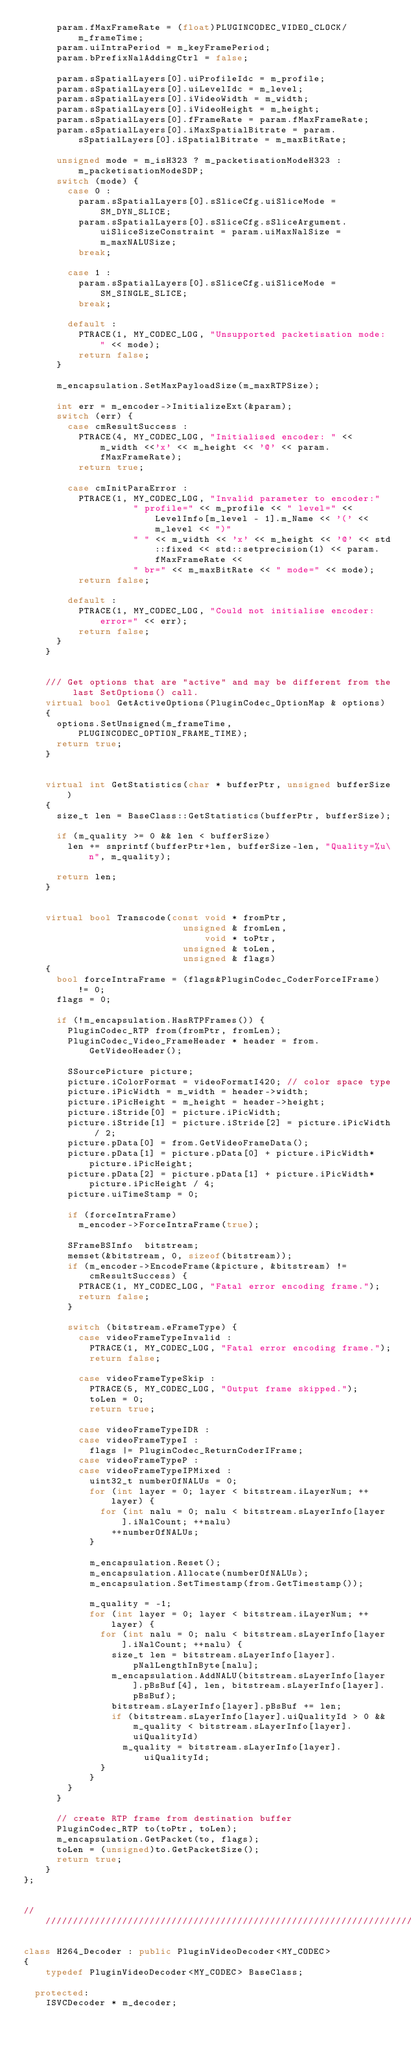<code> <loc_0><loc_0><loc_500><loc_500><_C++_>      param.fMaxFrameRate = (float)PLUGINCODEC_VIDEO_CLOCK/m_frameTime;
      param.uiIntraPeriod = m_keyFramePeriod;
      param.bPrefixNalAddingCtrl = false;

      param.sSpatialLayers[0].uiProfileIdc = m_profile;
      param.sSpatialLayers[0].uiLevelIdc = m_level;
      param.sSpatialLayers[0].iVideoWidth = m_width;
      param.sSpatialLayers[0].iVideoHeight = m_height;
      param.sSpatialLayers[0].fFrameRate = param.fMaxFrameRate;
      param.sSpatialLayers[0].iMaxSpatialBitrate = param.sSpatialLayers[0].iSpatialBitrate = m_maxBitRate;

      unsigned mode = m_isH323 ? m_packetisationModeH323 : m_packetisationModeSDP;
      switch (mode) {
        case 0 :
          param.sSpatialLayers[0].sSliceCfg.uiSliceMode = SM_DYN_SLICE;
          param.sSpatialLayers[0].sSliceCfg.sSliceArgument.uiSliceSizeConstraint = param.uiMaxNalSize = m_maxNALUSize;
          break;

        case 1 :
          param.sSpatialLayers[0].sSliceCfg.uiSliceMode = SM_SINGLE_SLICE;
          break;

        default :
          PTRACE(1, MY_CODEC_LOG, "Unsupported packetisation mode: " << mode);
          return false;
      }

      m_encapsulation.SetMaxPayloadSize(m_maxRTPSize);

      int err = m_encoder->InitializeExt(&param);
      switch (err) {
        case cmResultSuccess :
          PTRACE(4, MY_CODEC_LOG, "Initialised encoder: " << m_width <<'x' << m_height << '@' << param.fMaxFrameRate);
          return true;

        case cmInitParaError :
          PTRACE(1, MY_CODEC_LOG, "Invalid parameter to encoder:"
                    " profile=" << m_profile << " level=" << LevelInfo[m_level - 1].m_Name << '(' << m_level << ")"
                    " " << m_width << 'x' << m_height << '@' << std::fixed << std::setprecision(1) << param.fMaxFrameRate <<
                    " br=" << m_maxBitRate << " mode=" << mode);
          return false;

        default :
          PTRACE(1, MY_CODEC_LOG, "Could not initialise encoder: error=" << err);
          return false;
      }
    }


    /// Get options that are "active" and may be different from the last SetOptions() call.
    virtual bool GetActiveOptions(PluginCodec_OptionMap & options)
    {
      options.SetUnsigned(m_frameTime, PLUGINCODEC_OPTION_FRAME_TIME);
      return true;
    }


    virtual int GetStatistics(char * bufferPtr, unsigned bufferSize)
    {
      size_t len = BaseClass::GetStatistics(bufferPtr, bufferSize);

      if (m_quality >= 0 && len < bufferSize)
        len += snprintf(bufferPtr+len, bufferSize-len, "Quality=%u\n", m_quality);

      return len;
    }


    virtual bool Transcode(const void * fromPtr,
                             unsigned & fromLen,
                                 void * toPtr,
                             unsigned & toLen,
                             unsigned & flags)
    {
      bool forceIntraFrame = (flags&PluginCodec_CoderForceIFrame) != 0;
      flags = 0;

      if (!m_encapsulation.HasRTPFrames()) {
        PluginCodec_RTP from(fromPtr, fromLen);
        PluginCodec_Video_FrameHeader * header = from.GetVideoHeader();

        SSourcePicture picture;
        picture.iColorFormat = videoFormatI420;	// color space type
        picture.iPicWidth = m_width = header->width;
        picture.iPicHeight = m_height = header->height;
        picture.iStride[0] = picture.iPicWidth;
        picture.iStride[1] = picture.iStride[2] = picture.iPicWidth / 2;
        picture.pData[0] = from.GetVideoFrameData();
        picture.pData[1] = picture.pData[0] + picture.iPicWidth*picture.iPicHeight;
        picture.pData[2] = picture.pData[1] + picture.iPicWidth*picture.iPicHeight / 4;
        picture.uiTimeStamp = 0;

        if (forceIntraFrame)
          m_encoder->ForceIntraFrame(true);

        SFrameBSInfo  bitstream;
        memset(&bitstream, 0, sizeof(bitstream));
        if (m_encoder->EncodeFrame(&picture, &bitstream) != cmResultSuccess) {
          PTRACE(1, MY_CODEC_LOG, "Fatal error encoding frame.");
          return false;
        }

        switch (bitstream.eFrameType) {
          case videoFrameTypeInvalid :
            PTRACE(1, MY_CODEC_LOG, "Fatal error encoding frame.");
            return false;

          case videoFrameTypeSkip :
            PTRACE(5, MY_CODEC_LOG, "Output frame skipped.");
            toLen = 0;
            return true;

          case videoFrameTypeIDR :
          case videoFrameTypeI :
            flags |= PluginCodec_ReturnCoderIFrame;
          case videoFrameTypeP :
          case videoFrameTypeIPMixed :
            uint32_t numberOfNALUs = 0;
            for (int layer = 0; layer < bitstream.iLayerNum; ++layer) {
              for (int nalu = 0; nalu < bitstream.sLayerInfo[layer].iNalCount; ++nalu)
                ++numberOfNALUs;
            }

            m_encapsulation.Reset();
            m_encapsulation.Allocate(numberOfNALUs);
            m_encapsulation.SetTimestamp(from.GetTimestamp());

            m_quality = -1;
            for (int layer = 0; layer < bitstream.iLayerNum; ++layer) {
              for (int nalu = 0; nalu < bitstream.sLayerInfo[layer].iNalCount; ++nalu) {
                size_t len = bitstream.sLayerInfo[layer].pNalLengthInByte[nalu];
                m_encapsulation.AddNALU(bitstream.sLayerInfo[layer].pBsBuf[4], len, bitstream.sLayerInfo[layer].pBsBuf);
                bitstream.sLayerInfo[layer].pBsBuf += len;
                if (bitstream.sLayerInfo[layer].uiQualityId > 0 && m_quality < bitstream.sLayerInfo[layer].uiQualityId)
                  m_quality = bitstream.sLayerInfo[layer].uiQualityId;
              }
            }
        }
      }

      // create RTP frame from destination buffer
      PluginCodec_RTP to(toPtr, toLen);
      m_encapsulation.GetPacket(to, flags);
      toLen = (unsigned)to.GetPacketSize();
      return true;
    }
};


///////////////////////////////////////////////////////////////////////////////

class H264_Decoder : public PluginVideoDecoder<MY_CODEC>
{
    typedef PluginVideoDecoder<MY_CODEC> BaseClass;

  protected:
    ISVCDecoder * m_decoder;</code> 